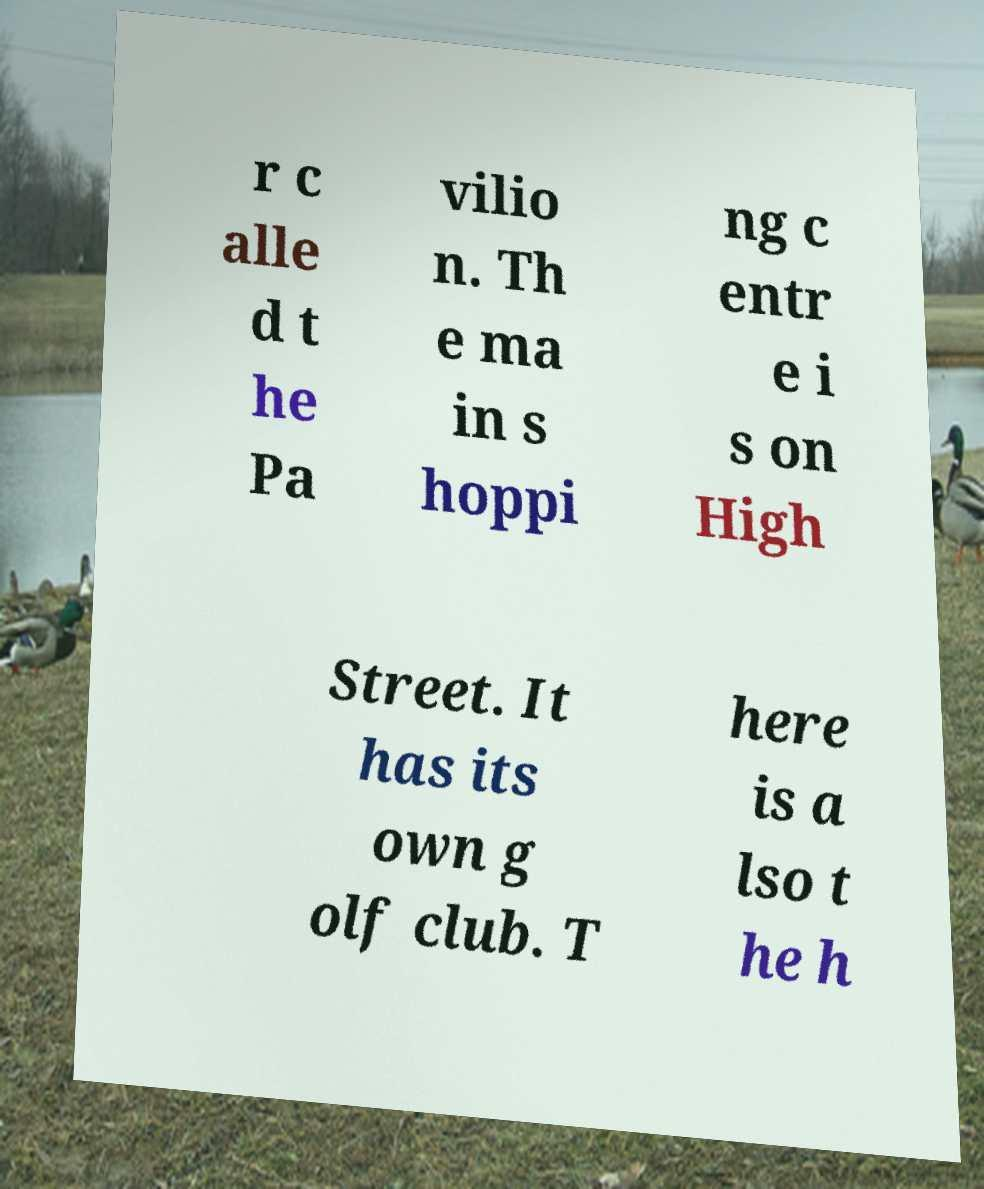Please identify and transcribe the text found in this image. r c alle d t he Pa vilio n. Th e ma in s hoppi ng c entr e i s on High Street. It has its own g olf club. T here is a lso t he h 